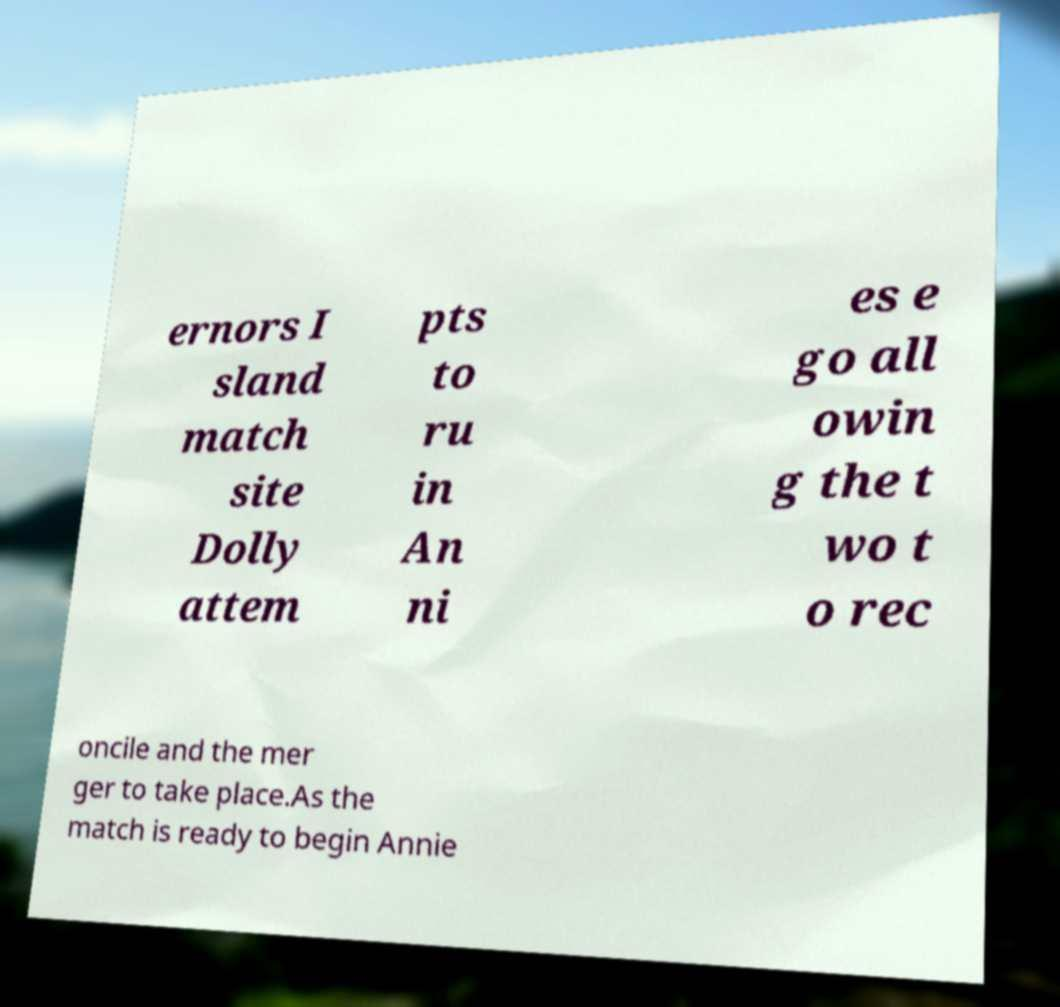Could you assist in decoding the text presented in this image and type it out clearly? ernors I sland match site Dolly attem pts to ru in An ni es e go all owin g the t wo t o rec oncile and the mer ger to take place.As the match is ready to begin Annie 